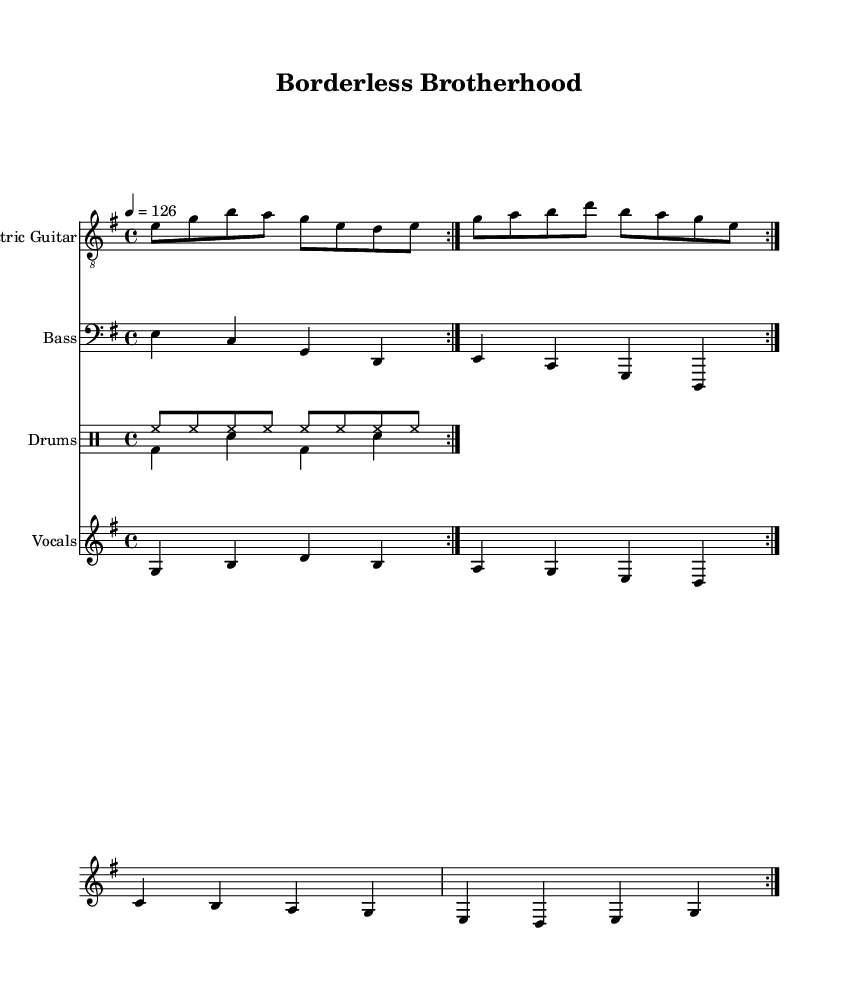What is the key signature of this music? The key signature is E minor, which appears at the beginning of the sheet music indicating that there is one sharp (F#).
Answer: E minor What is the time signature of the piece? The time signature is 4/4, indicated in the opening section of the sheet music, which means there are four beats in a measure.
Answer: 4/4 What is the tempo marking for the music? The tempo marking is 126 beats per minute, which specifies how fast the piece should be played.
Answer: 126 How many times is the verse repeated? The verse is repeated twice, as indicated by the repeat marks present in the vocal line.
Answer: 2 What instrument plays the main melody in this piece? The Electric Guitar plays the main melody, which is evident as it is highlighted at the beginning of the score.
Answer: Electric Guitar What is the main theme expressed in the lyrics? The main theme expressed in the lyrics is friendship and unity across borders, which is emphasized in the phrasing and content of the lyrics.
Answer: Friendship and unity What type of musical genre does this piece belong to? This piece belongs to the Hard Rock genre, which can be inferred from the instrumentation, rhythm, and overall style presented in the score.
Answer: Hard Rock 